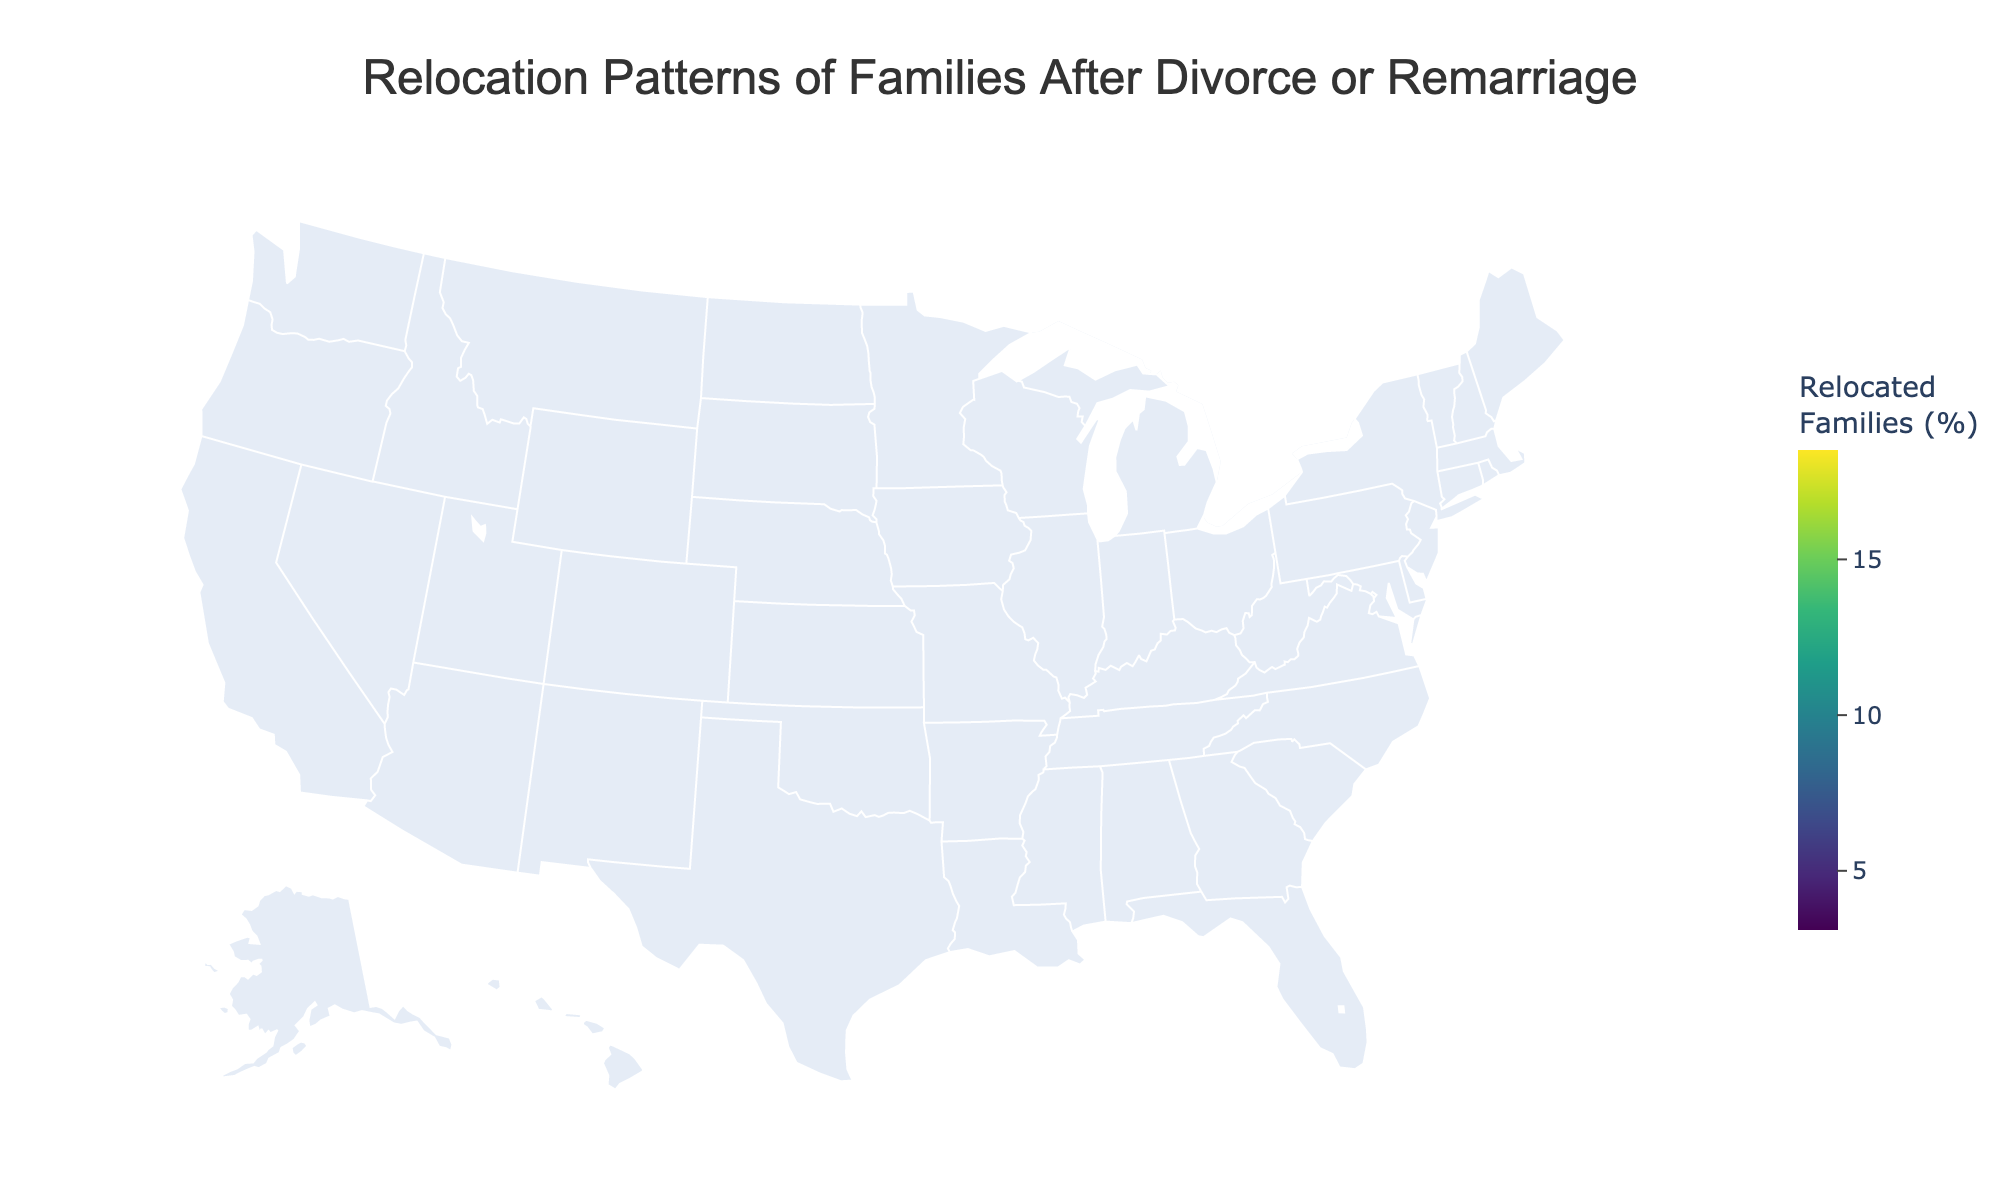Which state has the highest percentage of relocated families? The figure shows states colored based on the percentage of relocated families. California is highlighted with the highest intensity, indicating the highest percentage.
Answer: California What is the title of the figure? The title is prominently displayed at the top-center of the figure, providing a summary of what the plot represents.
Answer: Relocation Patterns of Families After Divorce or Remarriage Which states have a relocation percentage above 10? Observing the choropleth map and the color scale, states with higher intensities, which are above the 10% mark, include California, Texas, Florida, and New York.
Answer: California, Texas, Florida, New York What is the top destination city for Florida? Hovering over Florida on the map or observing any annotations provides the top destination city for the state.
Answer: Orlando Which has a higher percentage of relocated families, Georgia or Virginia? By comparing the color intensities and labels for Georgia and Virginia, it's clear that Georgia has a higher percentage. Georgia shows 5.2% while Virginia shows 4.7%.
Answer: Georgia How many states have more than 8% of relocated families? Count the states that have a percentage higher than 8%, which include California, Texas, Florida, New York, and Arizona. The counting process gives a total of five states.
Answer: 5 What is the percentage difference in relocated families between Texas and Arizona? Look at the percentage values for Texas (15.2%) and Arizona (8.9%). Subtract Arizona's percentage from Texas's percentage: 15.2% - 8.9% = 6.3%.
Answer: 6.3% What appears to be the most common top destination city among the states listed? The figure provides the top destination cities annotated or in hover data. Checking each state reveals that no city is common among multiple states.
Answer: None Which state has the lowest percentage of relocated families, and what is that percentage? The state with the least color intensity or the lowest percentage label, which in this case is Massachusetts with 3.1%.
Answer: Massachusetts, 3.1% What’s the total percentage of relocated families for Colorado and Washington combined? The percentages for Colorado and Washington can be summed: 7.3% (Colorado) + 6.1% (Washington) = 13.4%.
Answer: 13.4% 